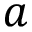Convert formula to latex. <formula><loc_0><loc_0><loc_500><loc_500>a</formula> 